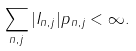Convert formula to latex. <formula><loc_0><loc_0><loc_500><loc_500>\sum _ { n , j } | I _ { n , j } | p _ { n , j } < \infty .</formula> 